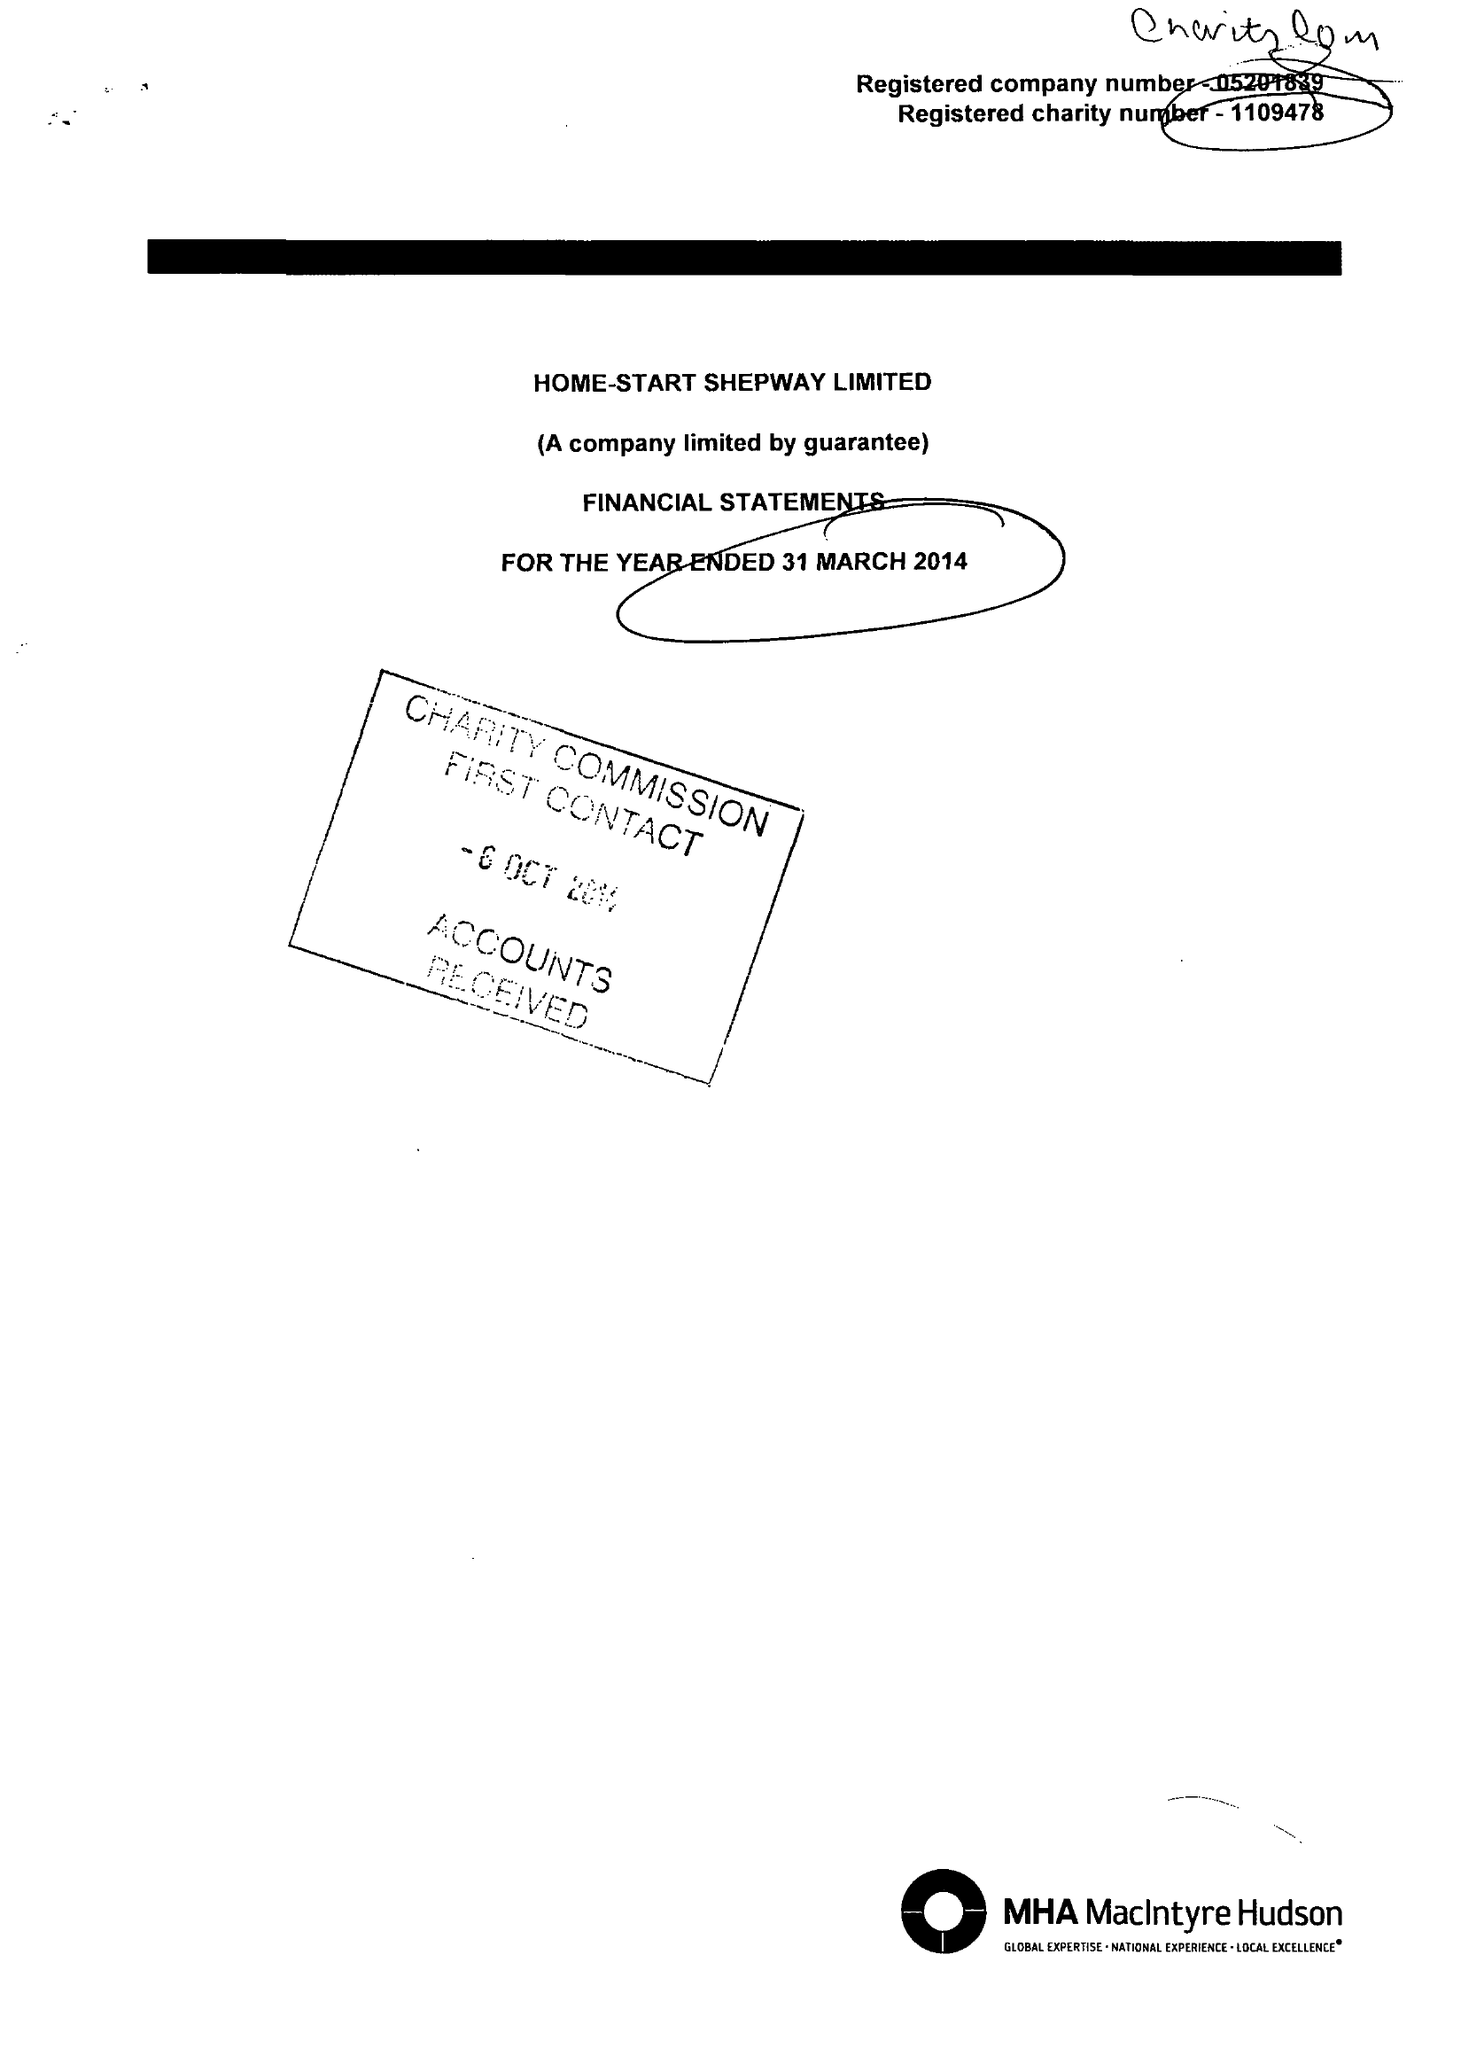What is the value for the address__post_town?
Answer the question using a single word or phrase. FOLKESTONE 